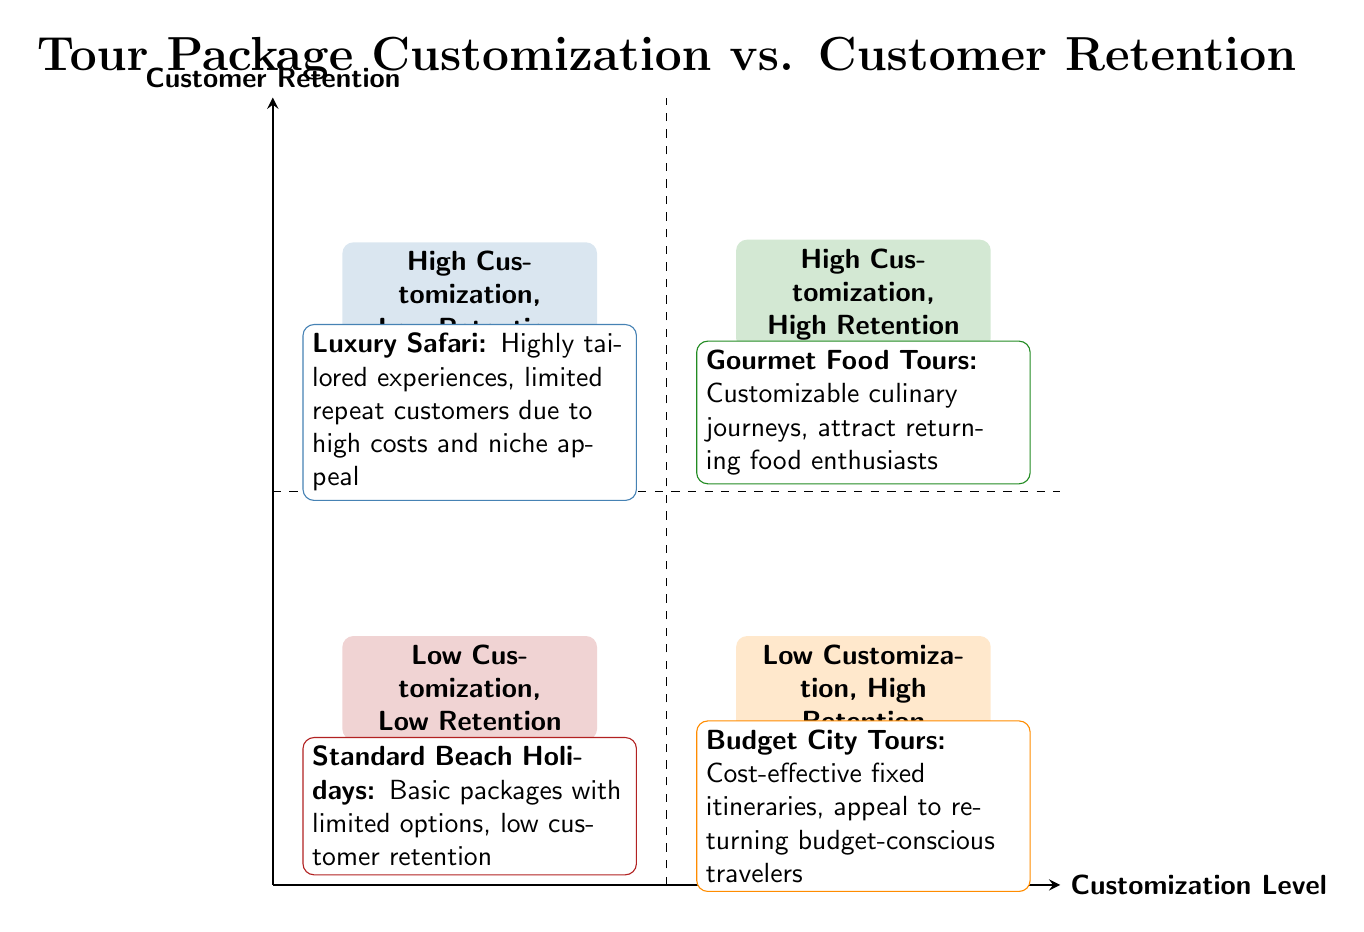What is the title of the top-left quadrant? The top-left quadrant is labeled "High Customization, Low Retention." This can be found by looking at the quadrant that shows high customization on the horizontal axis and low retention on the vertical axis.
Answer: High Customization, Low Retention How many examples are given in the bottom-left quadrant? In the bottom-left quadrant labeled "Low Customization, Low Retention," there is only one example provided, which is "Standard Beach Holidays." The number of examples is determined by counting the listed items in that specific quadrant.
Answer: 1 What type of tour is categorized in the top-right quadrant? The top-right quadrant features the "Gourmet Food Tours," which falls under the category of high customization and high retention. This can be established by analyzing the labels and examples provided in the respective quadrant.
Answer: Gourmet Food Tours Which quadrant has a focus on budget-conscious travelers? The quadrant labeled "Low Customization, High Retention" contains "Budget City Tours," which specifically appeal to budget-conscious travelers. This can be inferred by identifying the labels and descriptions of examples in each quadrant.
Answer: Low Customization, High Retention What is the relationship between "Luxury Safari" and customer retention? "Luxury Safari" is categorized in the "High Customization, Low Retention" quadrant, indicating that despite being tailored and exclusive, it has limited repeat customers, primarily due to high costs. This relationship is derived from the characteristics associated with that specific example and quadrant in the diagram.
Answer: Low Retention Which quadrant features standardized holiday experiences? The quadrant that showcases standardized holiday experiences is the "Low Customization, Low Retention" quadrant, highlighting "Standard Beach Holidays." This comes from reviewing the example descriptions and determining where standardization aligns with both low customization and retention.
Answer: Low Customization, Low Retention 